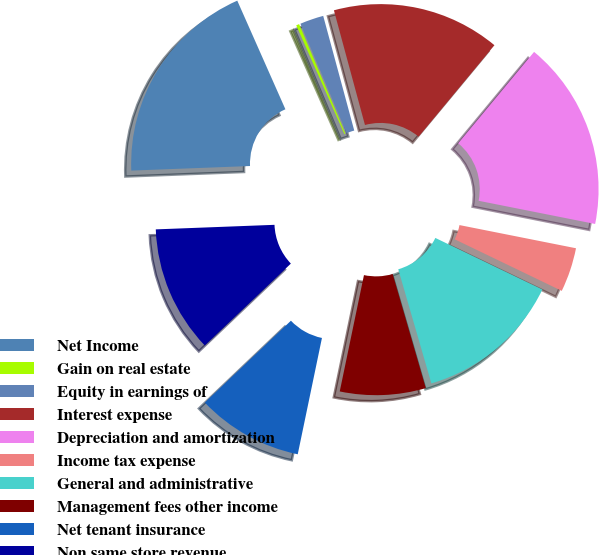<chart> <loc_0><loc_0><loc_500><loc_500><pie_chart><fcel>Net Income<fcel>Gain on real estate<fcel>Equity in earnings of<fcel>Interest expense<fcel>Depreciation and amortization<fcel>Income tax expense<fcel>General and administrative<fcel>Management fees other income<fcel>Net tenant insurance<fcel>Non same store revenue<nl><fcel>18.97%<fcel>0.28%<fcel>2.15%<fcel>15.23%<fcel>17.1%<fcel>4.02%<fcel>13.36%<fcel>7.76%<fcel>9.63%<fcel>11.49%<nl></chart> 